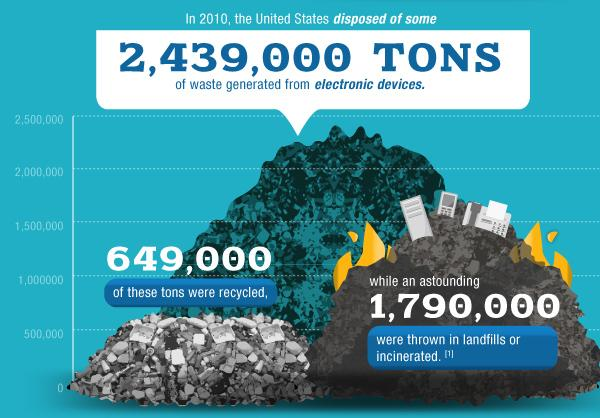Identify some key points in this picture. In the year 2020, 1,790,000 metric tons of electronic waste were disposed of in landfills. 